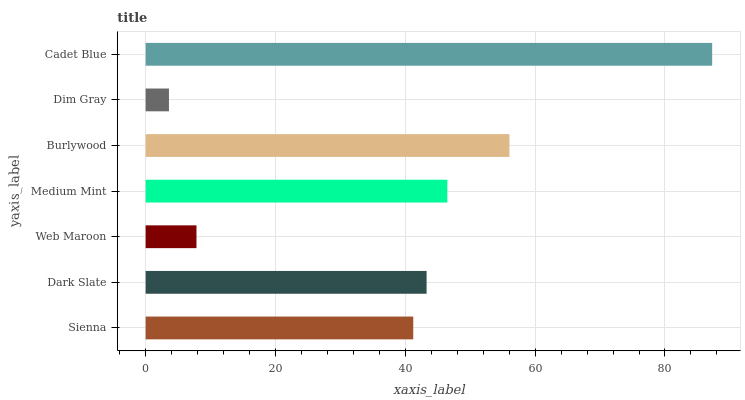Is Dim Gray the minimum?
Answer yes or no. Yes. Is Cadet Blue the maximum?
Answer yes or no. Yes. Is Dark Slate the minimum?
Answer yes or no. No. Is Dark Slate the maximum?
Answer yes or no. No. Is Dark Slate greater than Sienna?
Answer yes or no. Yes. Is Sienna less than Dark Slate?
Answer yes or no. Yes. Is Sienna greater than Dark Slate?
Answer yes or no. No. Is Dark Slate less than Sienna?
Answer yes or no. No. Is Dark Slate the high median?
Answer yes or no. Yes. Is Dark Slate the low median?
Answer yes or no. Yes. Is Dim Gray the high median?
Answer yes or no. No. Is Medium Mint the low median?
Answer yes or no. No. 